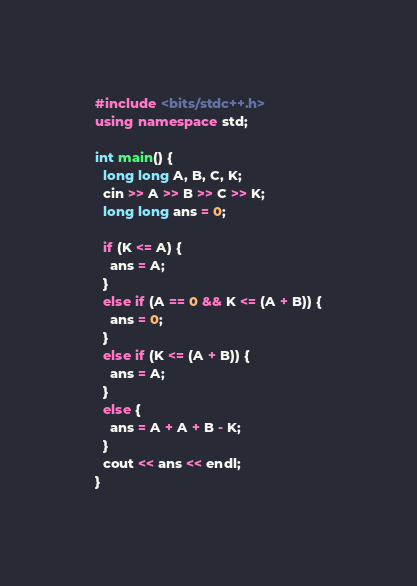Convert code to text. <code><loc_0><loc_0><loc_500><loc_500><_C++_>#include <bits/stdc++.h>
using namespace std;

int main() {
  long long A, B, C, K;
  cin >> A >> B >> C >> K;
  long long ans = 0;
  
  if (K <= A) {
    ans = A;
  }
  else if (A == 0 && K <= (A + B)) {
    ans = 0;
  }
  else if (K <= (A + B)) {
    ans = A;
  }
  else {
    ans = A + A + B - K;
  }
  cout << ans << endl;
}
</code> 